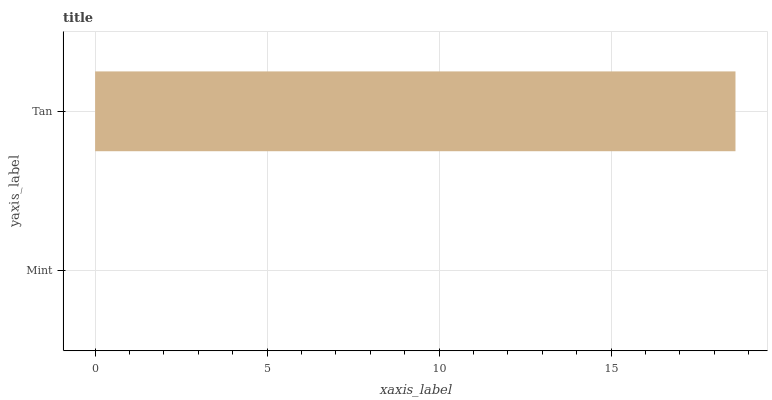Is Mint the minimum?
Answer yes or no. Yes. Is Tan the maximum?
Answer yes or no. Yes. Is Tan the minimum?
Answer yes or no. No. Is Tan greater than Mint?
Answer yes or no. Yes. Is Mint less than Tan?
Answer yes or no. Yes. Is Mint greater than Tan?
Answer yes or no. No. Is Tan less than Mint?
Answer yes or no. No. Is Tan the high median?
Answer yes or no. Yes. Is Mint the low median?
Answer yes or no. Yes. Is Mint the high median?
Answer yes or no. No. Is Tan the low median?
Answer yes or no. No. 